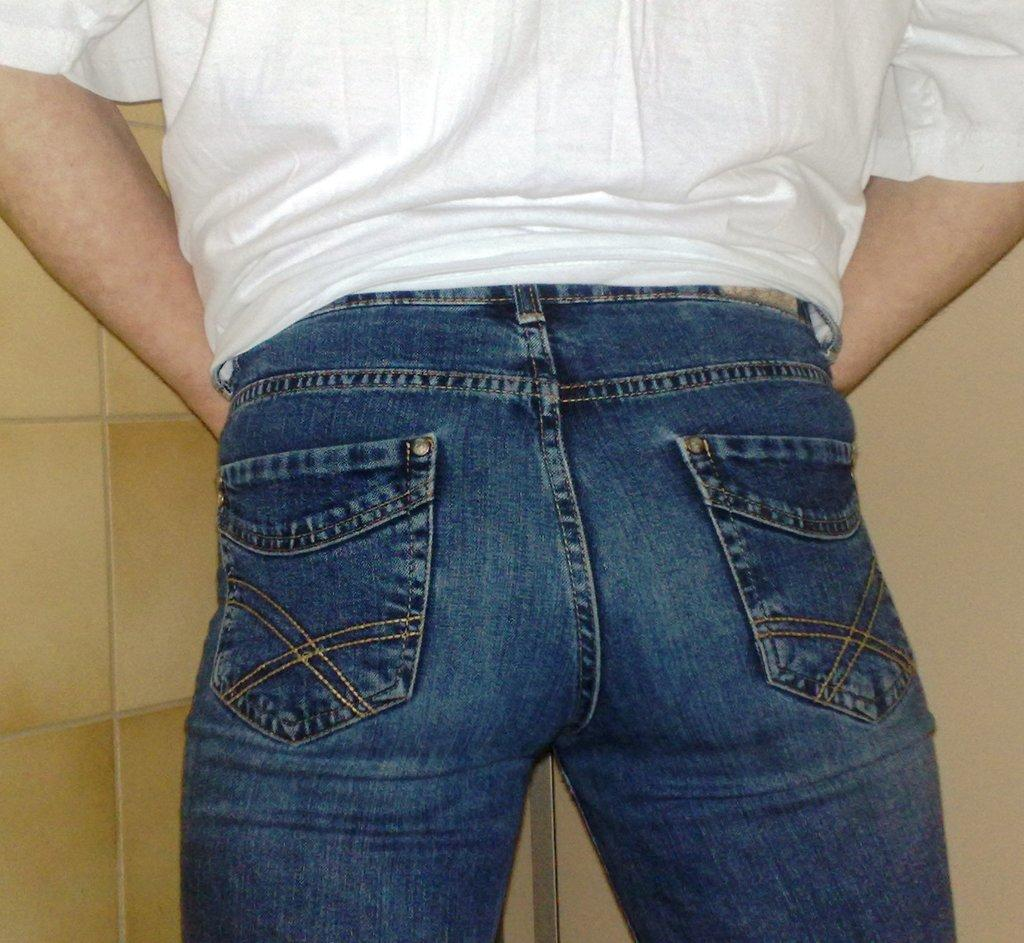What is the main subject of the image? There is a person in the image. What is the person wearing? The person is wearing a white t-shirt and blue pants. What is the person's posture in the image? The person is standing. What can be seen in the background of the image? There is a wall in the background of the image. What is a notable feature of the wall? There are tiles on the wall. What type of fowl can be seen perched on the person's shoulder in the image? There is no fowl present in the image; the person is standing alone. How many roses are visible on the person's shirt in the image? There are no roses visible on the person's shirt in the image; the person is wearing a plain white t-shirt. 